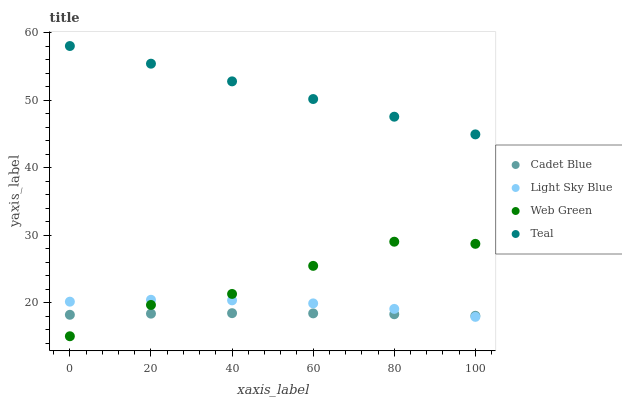Does Cadet Blue have the minimum area under the curve?
Answer yes or no. Yes. Does Teal have the maximum area under the curve?
Answer yes or no. Yes. Does Web Green have the minimum area under the curve?
Answer yes or no. No. Does Web Green have the maximum area under the curve?
Answer yes or no. No. Is Teal the smoothest?
Answer yes or no. Yes. Is Web Green the roughest?
Answer yes or no. Yes. Is Cadet Blue the smoothest?
Answer yes or no. No. Is Cadet Blue the roughest?
Answer yes or no. No. Does Web Green have the lowest value?
Answer yes or no. Yes. Does Cadet Blue have the lowest value?
Answer yes or no. No. Does Teal have the highest value?
Answer yes or no. Yes. Does Web Green have the highest value?
Answer yes or no. No. Is Light Sky Blue less than Teal?
Answer yes or no. Yes. Is Teal greater than Web Green?
Answer yes or no. Yes. Does Light Sky Blue intersect Cadet Blue?
Answer yes or no. Yes. Is Light Sky Blue less than Cadet Blue?
Answer yes or no. No. Is Light Sky Blue greater than Cadet Blue?
Answer yes or no. No. Does Light Sky Blue intersect Teal?
Answer yes or no. No. 